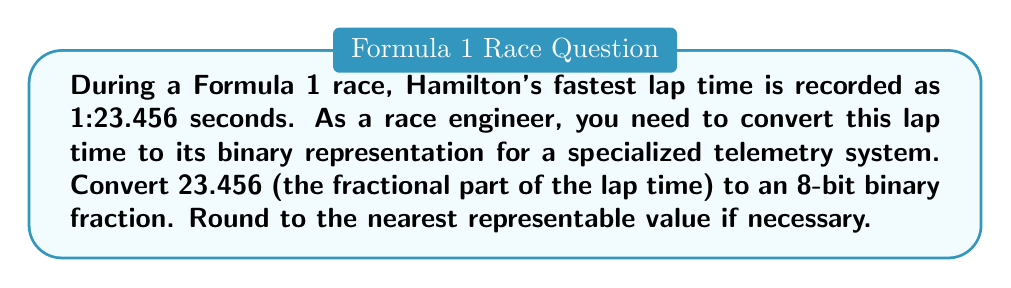Solve this math problem. To convert 23.456 to an 8-bit binary fraction, we need to follow these steps:

1) First, we separate the integer and fractional parts:
   Integer part: 23
   Fractional part: 0.456

2) We only need to convert the fractional part (0.456) to binary.

3) To convert the fractional part to binary, we repeatedly multiply by 2 and take the integer part as the binary digit:

   $0.456 \times 2 = 0.912$ (0)
   $0.912 \times 2 = 1.824$ (1)
   $0.824 \times 2 = 1.648$ (1)
   $0.648 \times 2 = 1.296$ (1)
   $0.296 \times 2 = 0.592$ (0)
   $0.592 \times 2 = 1.184$ (1)
   $0.184 \times 2 = 0.368$ (0)
   $0.368 \times 2 = 0.736$ (0)

4) Reading the digits in parentheses from top to bottom, we get:
   $0.456_{10} \approx 0.01110100_2$

5) This is an 8-bit representation, so we don't need to round further.

Therefore, the lap time 1:23.456 would be represented as:

$1:\texttt{10111}.01110100_2$

Where $\texttt{10111}_2 = 23_{10}$
Answer: $0.01110100_2$ 